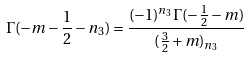<formula> <loc_0><loc_0><loc_500><loc_500>\Gamma ( - m - \frac { 1 } { 2 } - n _ { 3 } ) = \frac { ( - 1 ) ^ { n _ { 3 } } \Gamma ( - \frac { 1 } { 2 } - m ) } { ( \frac { 3 } { 2 } + m ) _ { n _ { 3 } } }</formula> 